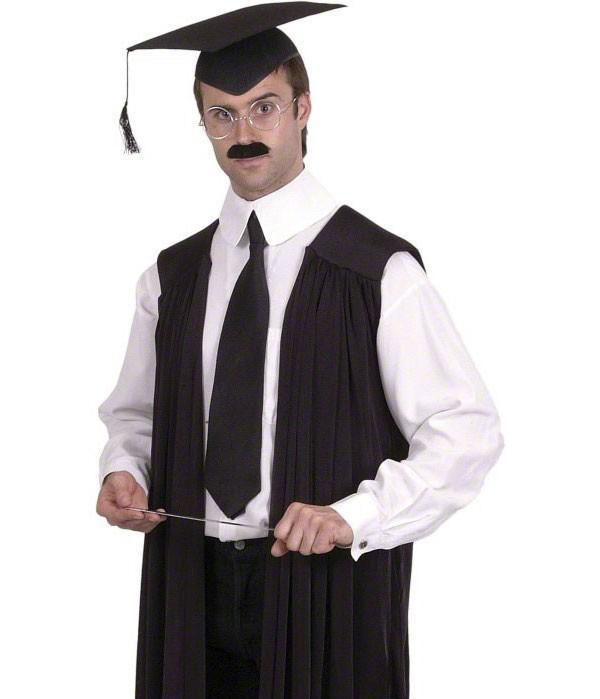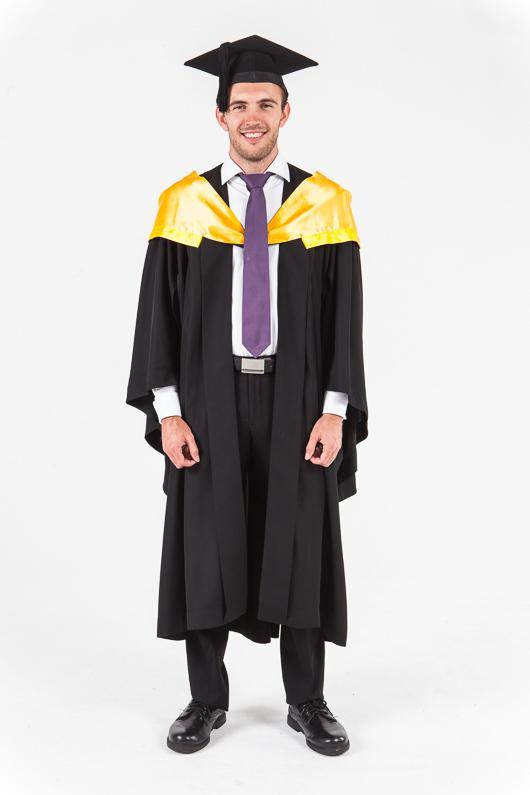The first image is the image on the left, the second image is the image on the right. Assess this claim about the two images: "White sleeves are almost completely exposed in one of the images.". Correct or not? Answer yes or no. Yes. 